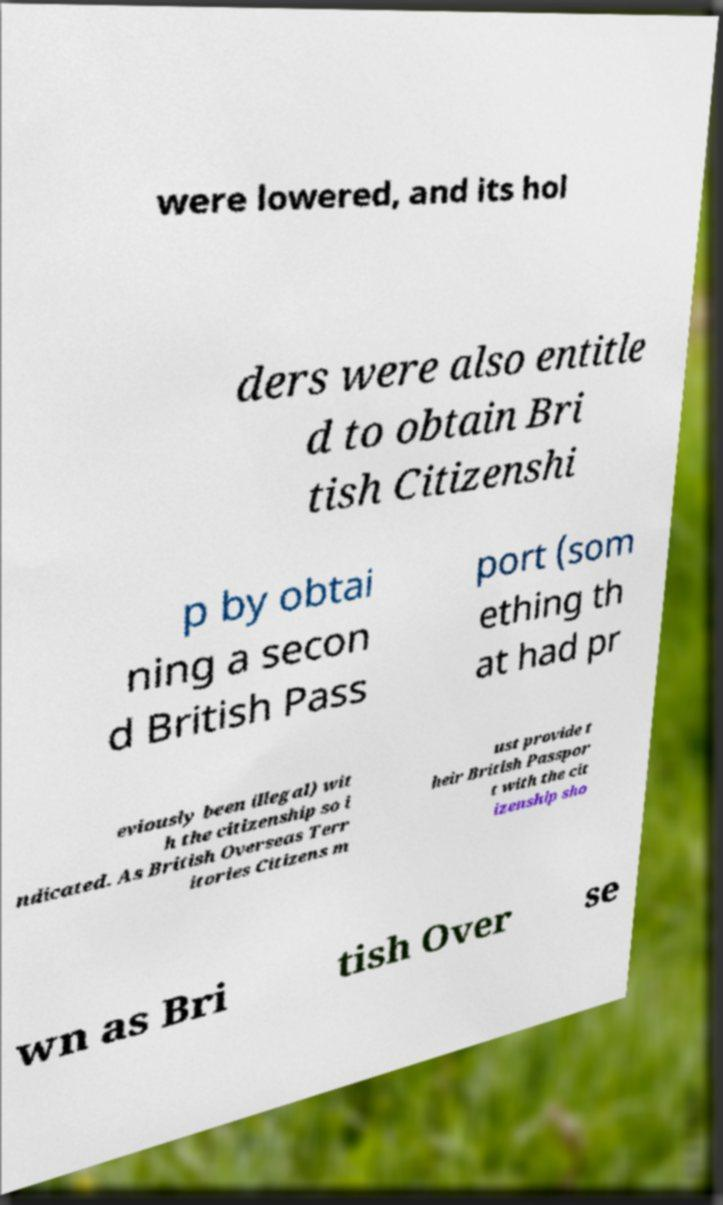Could you assist in decoding the text presented in this image and type it out clearly? were lowered, and its hol ders were also entitle d to obtain Bri tish Citizenshi p by obtai ning a secon d British Pass port (som ething th at had pr eviously been illegal) wit h the citizenship so i ndicated. As British Overseas Terr itories Citizens m ust provide t heir British Passpor t with the cit izenship sho wn as Bri tish Over se 